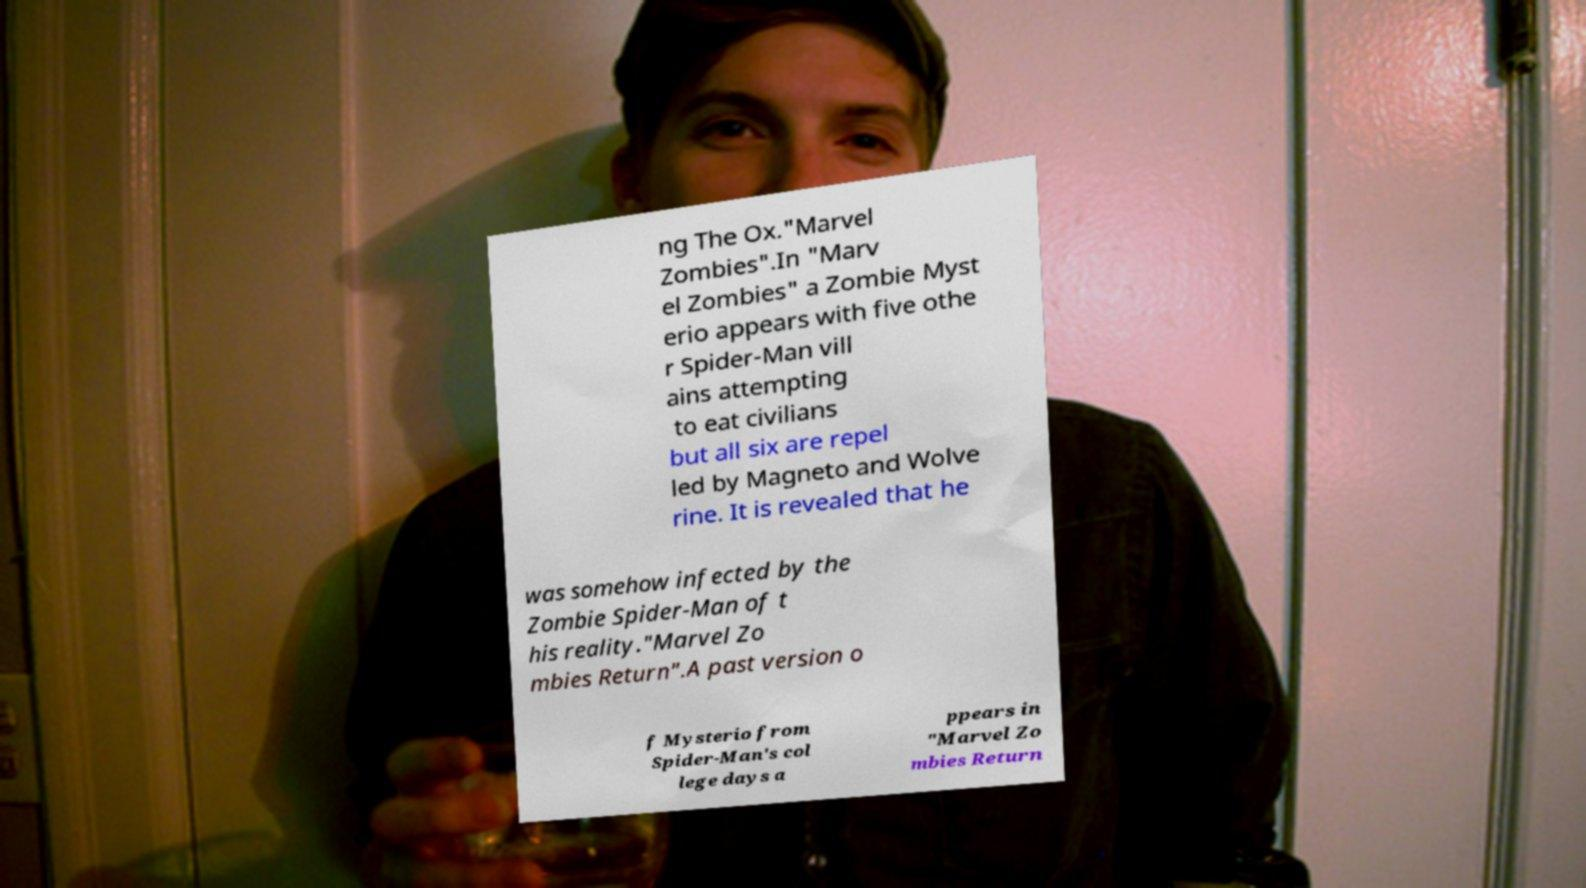What messages or text are displayed in this image? I need them in a readable, typed format. ng The Ox."Marvel Zombies".In "Marv el Zombies" a Zombie Myst erio appears with five othe r Spider-Man vill ains attempting to eat civilians but all six are repel led by Magneto and Wolve rine. It is revealed that he was somehow infected by the Zombie Spider-Man of t his reality."Marvel Zo mbies Return".A past version o f Mysterio from Spider-Man's col lege days a ppears in "Marvel Zo mbies Return 